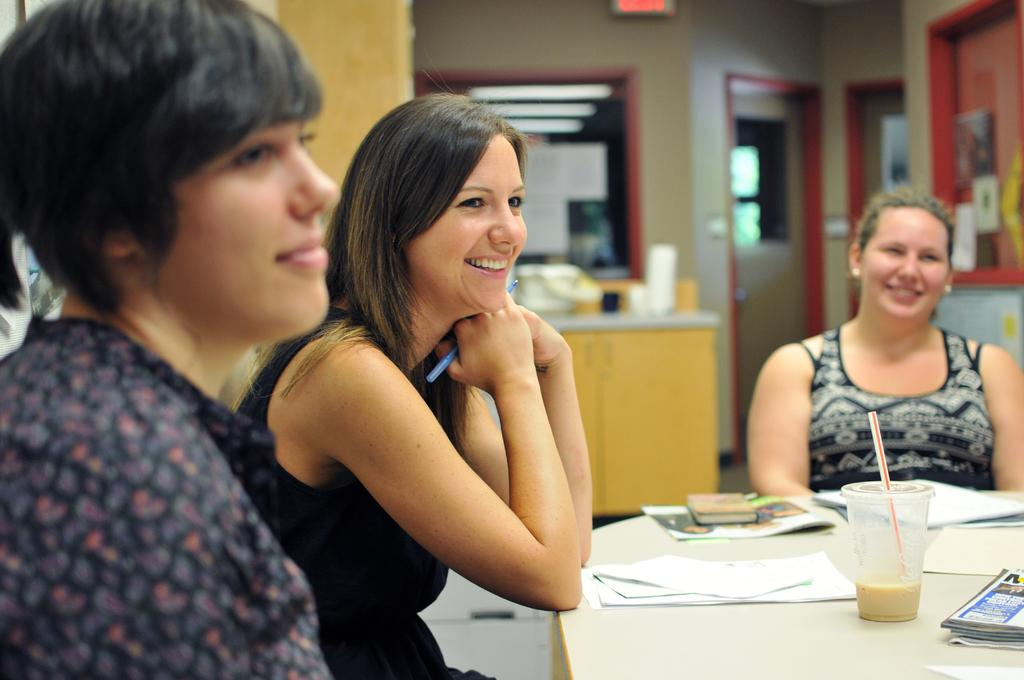Who is present in the image? There are women in the image. What are the women doing in the image? The women are sitting on chairs. What can be seen on the table in the image? There is a coffee glass and papers on the table. Where is the table located in relation to the women? The table is likely in front of the women, as they are sitting on chairs. What type of plane is visible in the image? There is no plane present in the image. What gate number is associated with the meeting in the image? There is no meeting or gate number mentioned in the image. 